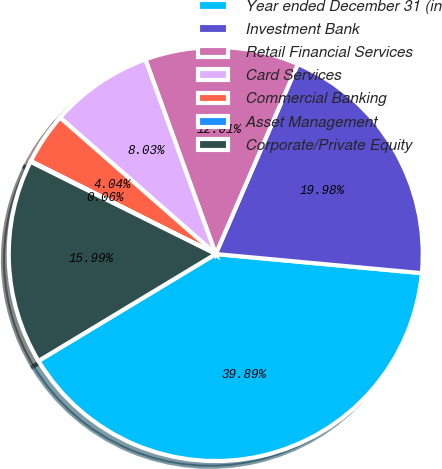Convert chart to OTSL. <chart><loc_0><loc_0><loc_500><loc_500><pie_chart><fcel>Year ended December 31 (in<fcel>Investment Bank<fcel>Retail Financial Services<fcel>Card Services<fcel>Commercial Banking<fcel>Asset Management<fcel>Corporate/Private Equity<nl><fcel>39.89%<fcel>19.98%<fcel>12.01%<fcel>8.03%<fcel>4.04%<fcel>0.06%<fcel>15.99%<nl></chart> 